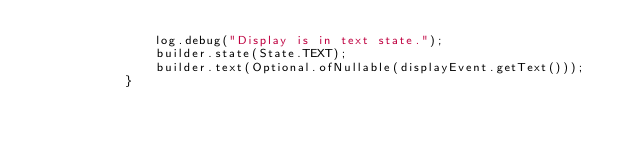<code> <loc_0><loc_0><loc_500><loc_500><_Java_>				log.debug("Display is in text state.");
				builder.state(State.TEXT);
				builder.text(Optional.ofNullable(displayEvent.getText()));
			}</code> 